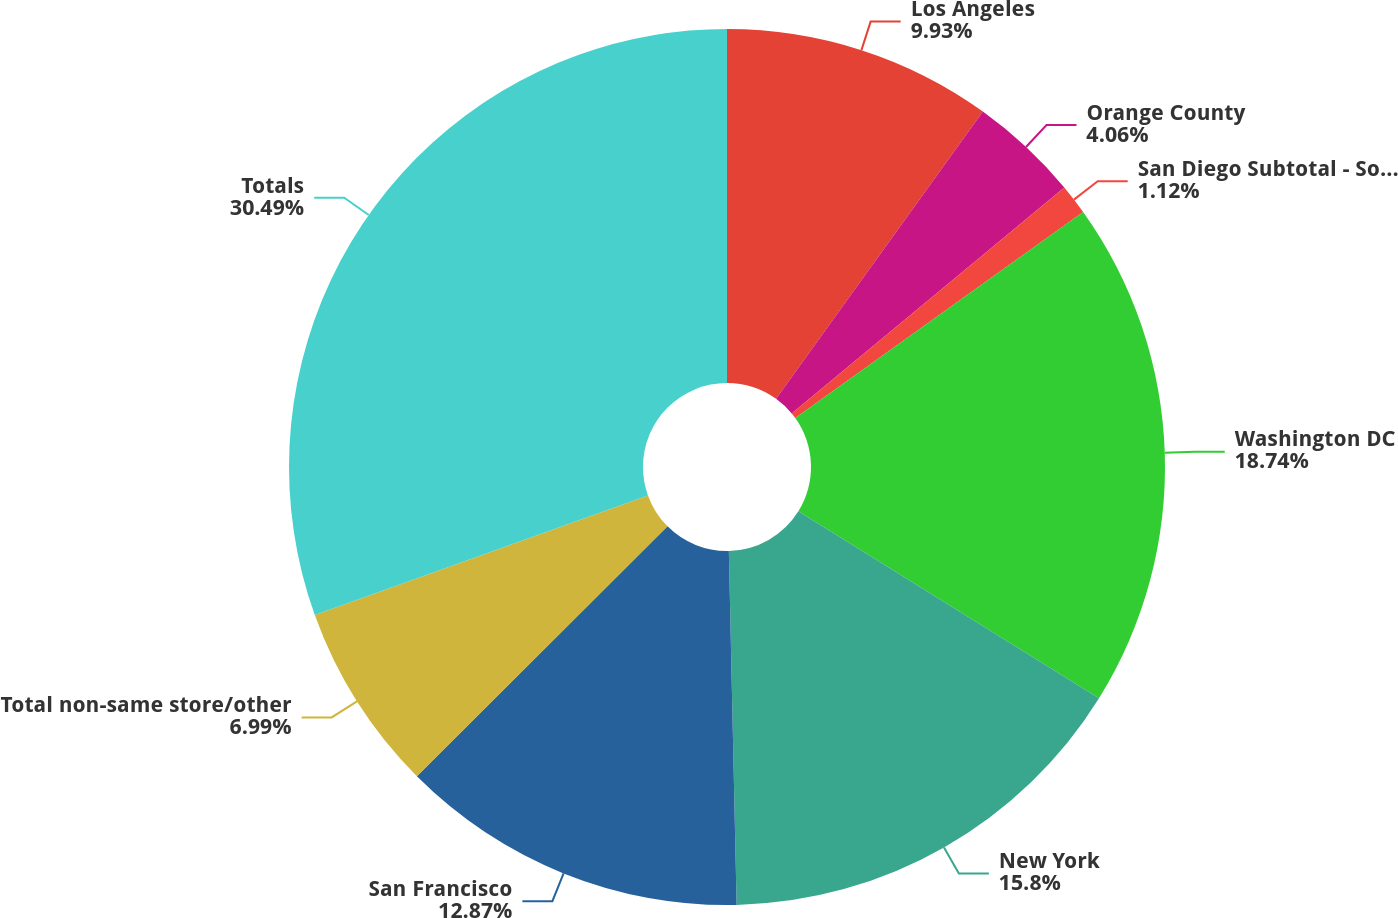<chart> <loc_0><loc_0><loc_500><loc_500><pie_chart><fcel>Los Angeles<fcel>Orange County<fcel>San Diego Subtotal - Southern<fcel>Washington DC<fcel>New York<fcel>San Francisco<fcel>Total non-same store/other<fcel>Totals<nl><fcel>9.93%<fcel>4.06%<fcel>1.12%<fcel>18.74%<fcel>15.8%<fcel>12.87%<fcel>6.99%<fcel>30.49%<nl></chart> 